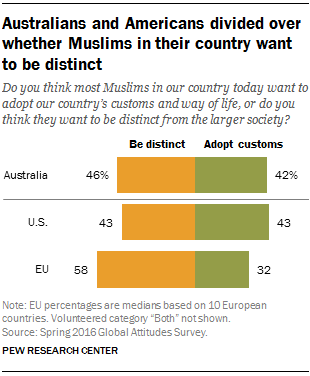Identify some key points in this picture. Green color represents the adoption of customs. In EU data, the ratio between adopting customs and being distinct is 1.373611111... 